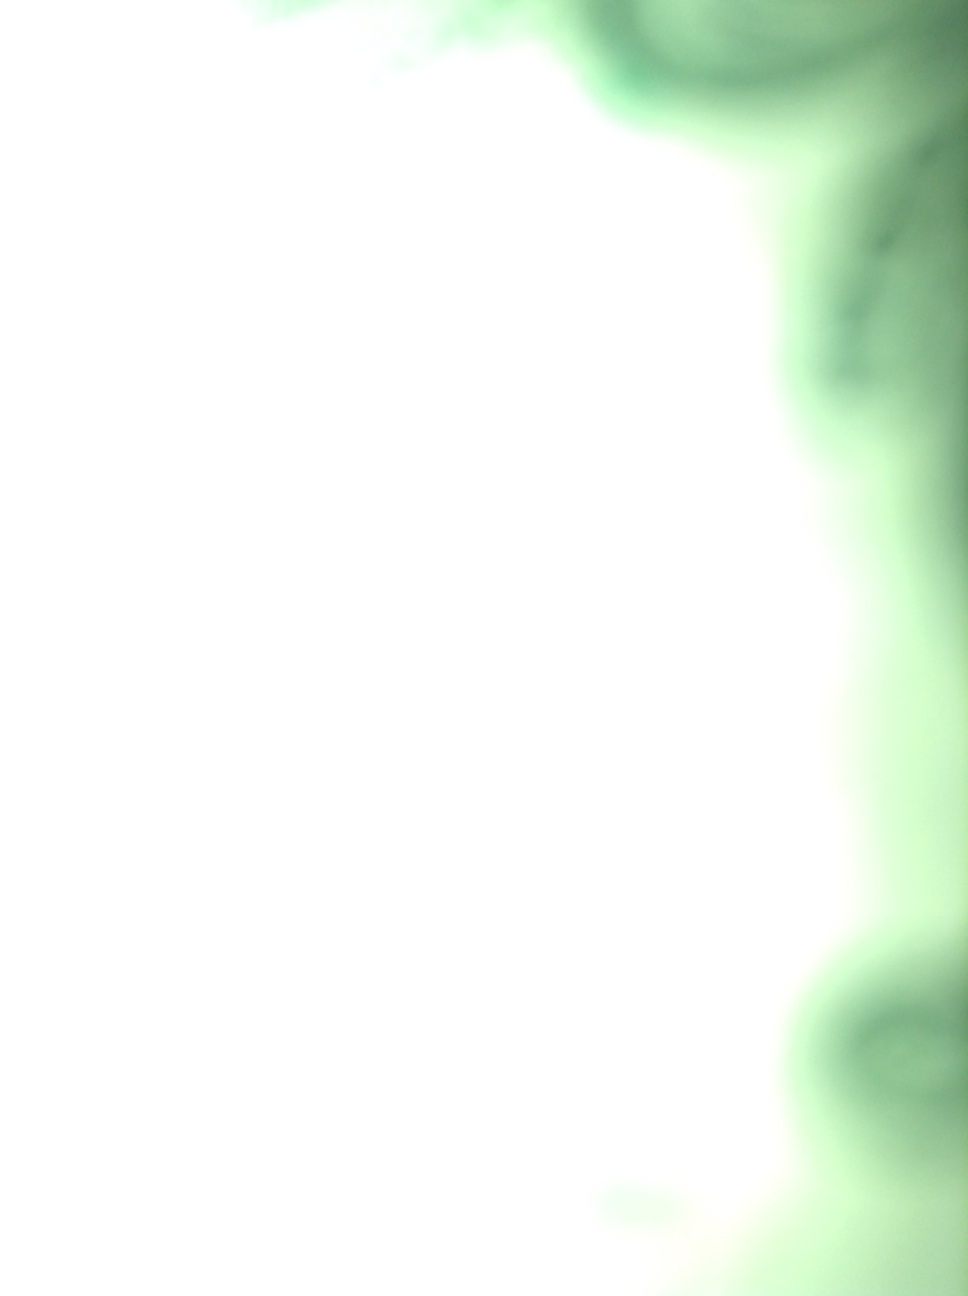Could you describe what you see in this image? The image is highly blurred and primarily exhibits a large area of bright green, making it challenging to discern any specific objects or details. 